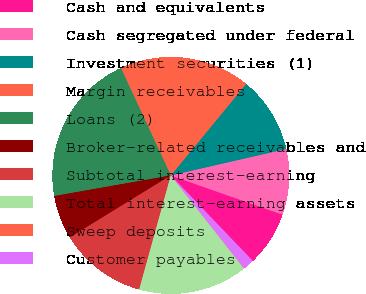Convert chart. <chart><loc_0><loc_0><loc_500><loc_500><pie_chart><fcel>Cash and equivalents<fcel>Cash segregated under federal<fcel>Investment securities (1)<fcel>Margin receivables<fcel>Loans (2)<fcel>Broker-related receivables and<fcel>Subtotal interest-earning<fcel>Total interest-earning assets<fcel>Sweep deposits<fcel>Customer payables<nl><fcel>7.47%<fcel>8.96%<fcel>10.45%<fcel>17.89%<fcel>20.86%<fcel>5.98%<fcel>11.93%<fcel>14.91%<fcel>0.03%<fcel>1.52%<nl></chart> 